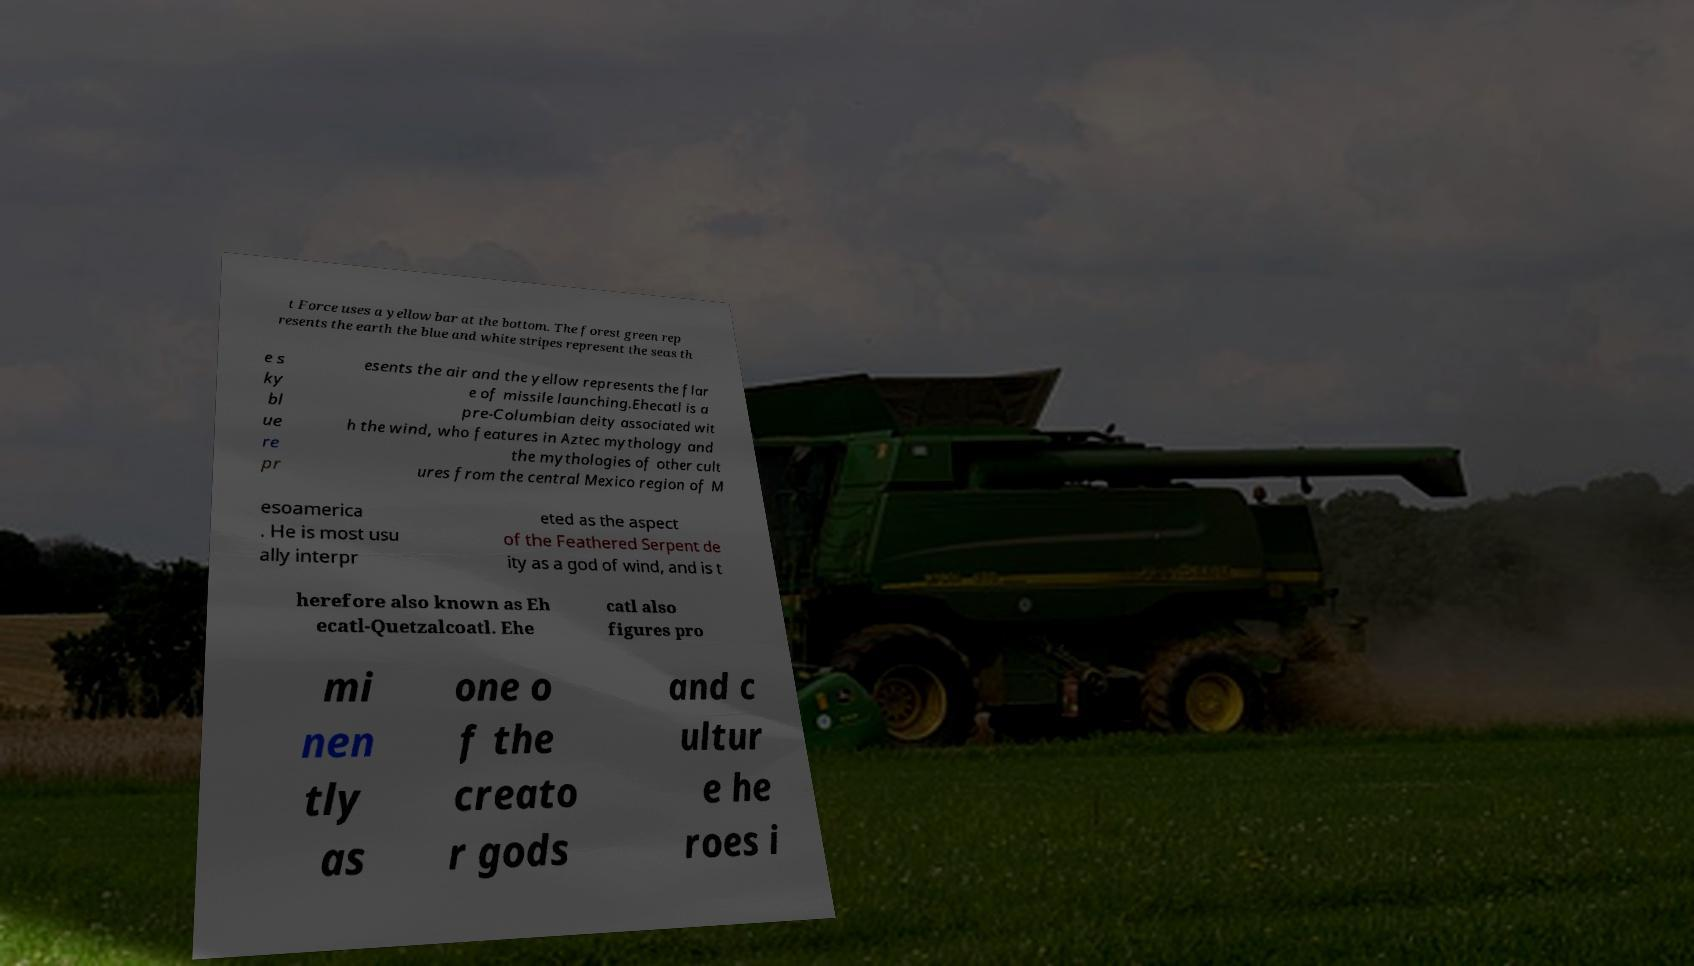Could you assist in decoding the text presented in this image and type it out clearly? t Force uses a yellow bar at the bottom. The forest green rep resents the earth the blue and white stripes represent the seas th e s ky bl ue re pr esents the air and the yellow represents the flar e of missile launching.Ehecatl is a pre-Columbian deity associated wit h the wind, who features in Aztec mythology and the mythologies of other cult ures from the central Mexico region of M esoamerica . He is most usu ally interpr eted as the aspect of the Feathered Serpent de ity as a god of wind, and is t herefore also known as Eh ecatl-Quetzalcoatl. Ehe catl also figures pro mi nen tly as one o f the creato r gods and c ultur e he roes i 